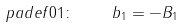<formula> <loc_0><loc_0><loc_500><loc_500>\ p a d e f { 0 } { 1 } \colon \quad b _ { 1 } = - B _ { 1 }</formula> 